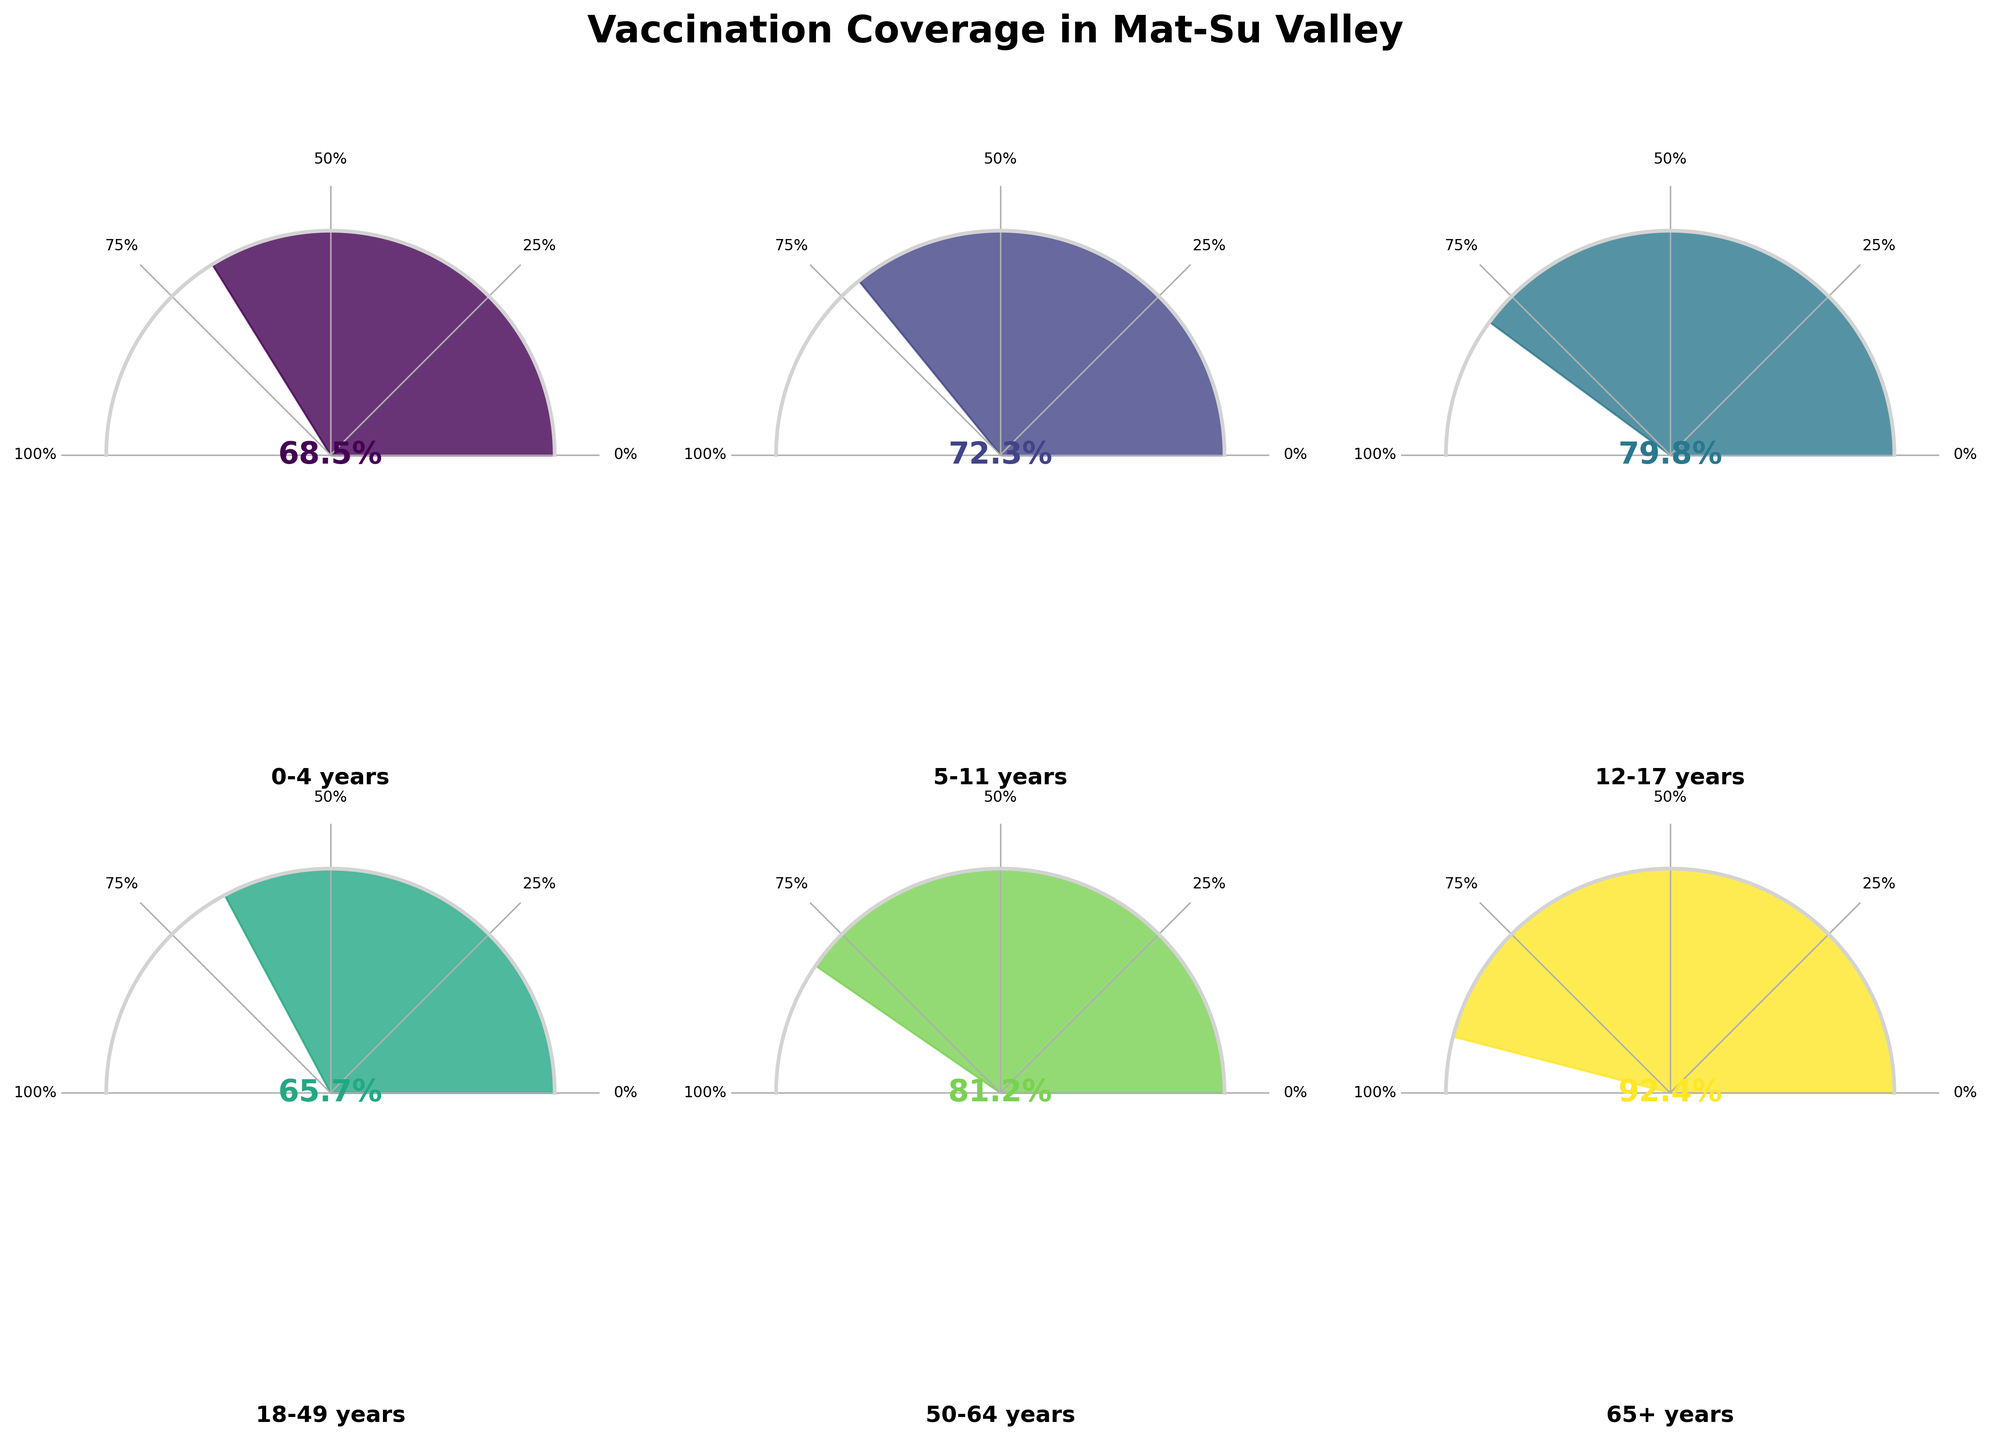What is the vaccination coverage percentage for the 65+ years age group? The gauge chart for the 65+ years age group shows a filled section corresponding to 92.4%, which is also displayed in large text at the center of the gauge.
Answer: 92.4% Which age group has the lowest vaccination coverage percentage? By comparing the filled sections and the percentages displayed at the center of each gauge chart, we can see that the 18-49 years age group has the lowest coverage at 65.7%.
Answer: 18-49 years What is the difference in vaccination coverage percentage between the 0-4 years and 5-11 years age groups? The 0-4 years age group has a coverage percentage of 68.5%, and the 5-11 years age group has a coverage percentage of 72.3%. Subtracting 68.5% from 72.3% gives 3.8%.
Answer: 3.8% How many age groups have a vaccination coverage percentage above 80%? By looking at the percentages displayed in the center of each gauge chart, we identify that 12-17 years (79.8%), 50-64 years (81.2%), and 65+ years (92.4%) have coverage above 80%. That totals 2 age groups.
Answer: 2 Which age group has the second highest vaccination coverage percentage? The highest percentage is 92.4% for the 65+ years age group. The next highest is 81.2% for the 50-64 years age group.
Answer: 50-64 years What is the average vaccination coverage percentage across all age groups? Add all percentages: 68.5 + 72.3 + 79.8 + 65.7 + 81.2 + 92.4 = 459.9. Divide by the number of age groups (6): 459.9 / 6 = 76.65.
Answer: 76.65% Is the vaccination coverage percentage for the 0-4 years age group higher or lower than that of the 12-17 years age group? Comparing the percentages, 68.5% (0-4 years) is lower than 79.8% (12-17 years).
Answer: Lower What is the collective vaccination coverage percentage for the age groups below 18 years? Sum the percentages of the age groups 0-4 years (68.5), 5-11 years (72.3), and 12-17 years (79.8): 68.5 + 72.3 + 79.8 = 220.6.
Answer: 220.6 Which age group has a vaccination coverage percentage closest to 75%? The 5-11 years age group has a coverage percentage of 72.3%, closest to 75%.
Answer: 5-11 years 